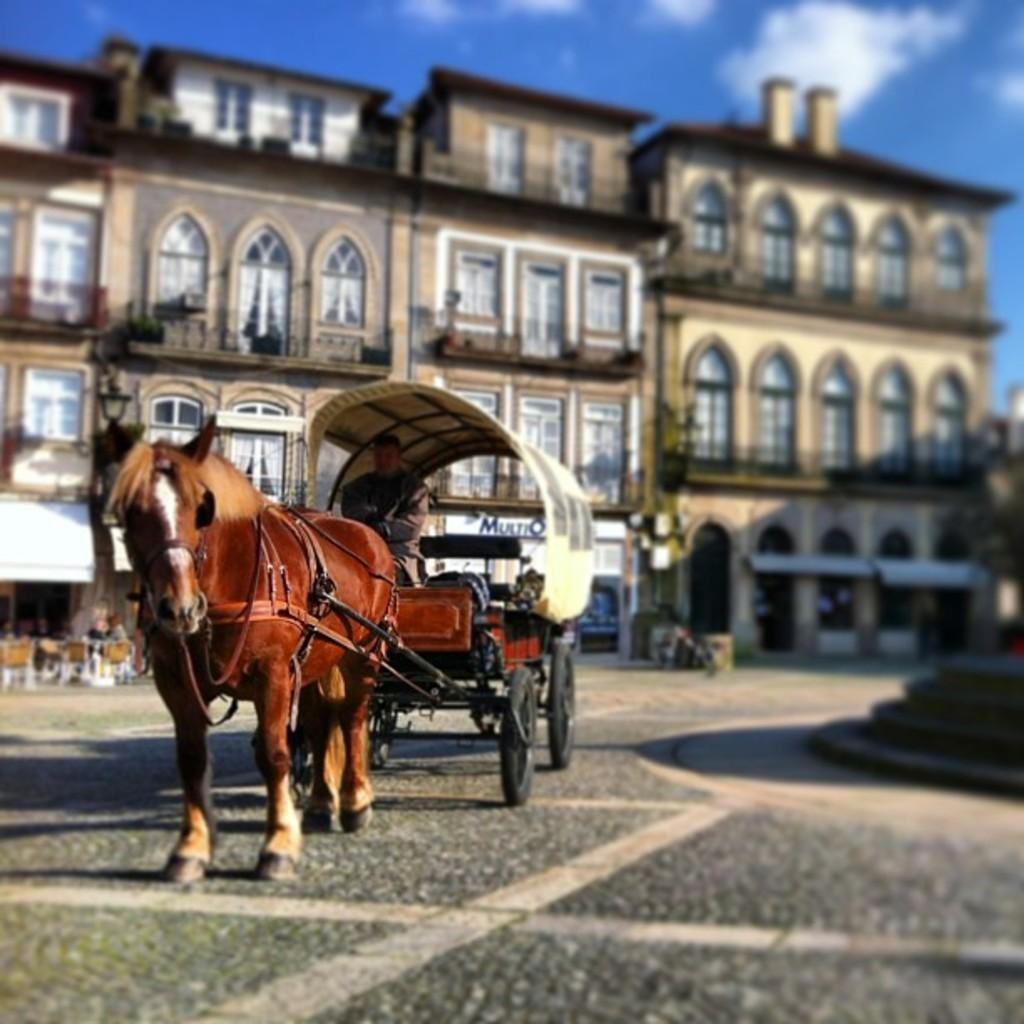What is on the ground in the image? There is a horse cart on the ground in the image. Who or what is present in the image? There is a person in the image. What else can be seen in the image besides the horse cart and person? There are objects in the image. What can be seen in the distance in the image? There are buildings in the background of the image. What is visible in the sky in the image? The sky is visible in the background of the image, and clouds are present. What type of road is visible in the image? There is no road visible in the image; it features a horse cart on the ground, a person, objects, buildings, and the sky. 